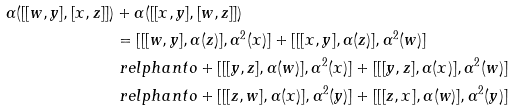Convert formula to latex. <formula><loc_0><loc_0><loc_500><loc_500>\alpha ( [ [ w , y ] , [ x , z ] ] ) & + \alpha ( [ [ x , y ] , [ w , z ] ] ) \\ & = [ [ [ w , y ] , \alpha ( z ) ] , \alpha ^ { 2 } ( x ) ] + [ [ [ x , y ] , \alpha ( z ) ] , \alpha ^ { 2 } ( w ) ] \\ & \ r e l p h a n t o + [ [ [ y , z ] , \alpha ( w ) ] , \alpha ^ { 2 } ( x ) ] + [ [ [ y , z ] , \alpha ( x ) ] , \alpha ^ { 2 } ( w ) ] \\ & \ r e l p h a n t o + [ [ [ z , w ] , \alpha ( x ) ] , \alpha ^ { 2 } ( y ) ] + [ [ [ z , x ] , \alpha ( w ) ] , \alpha ^ { 2 } ( y ) ]</formula> 